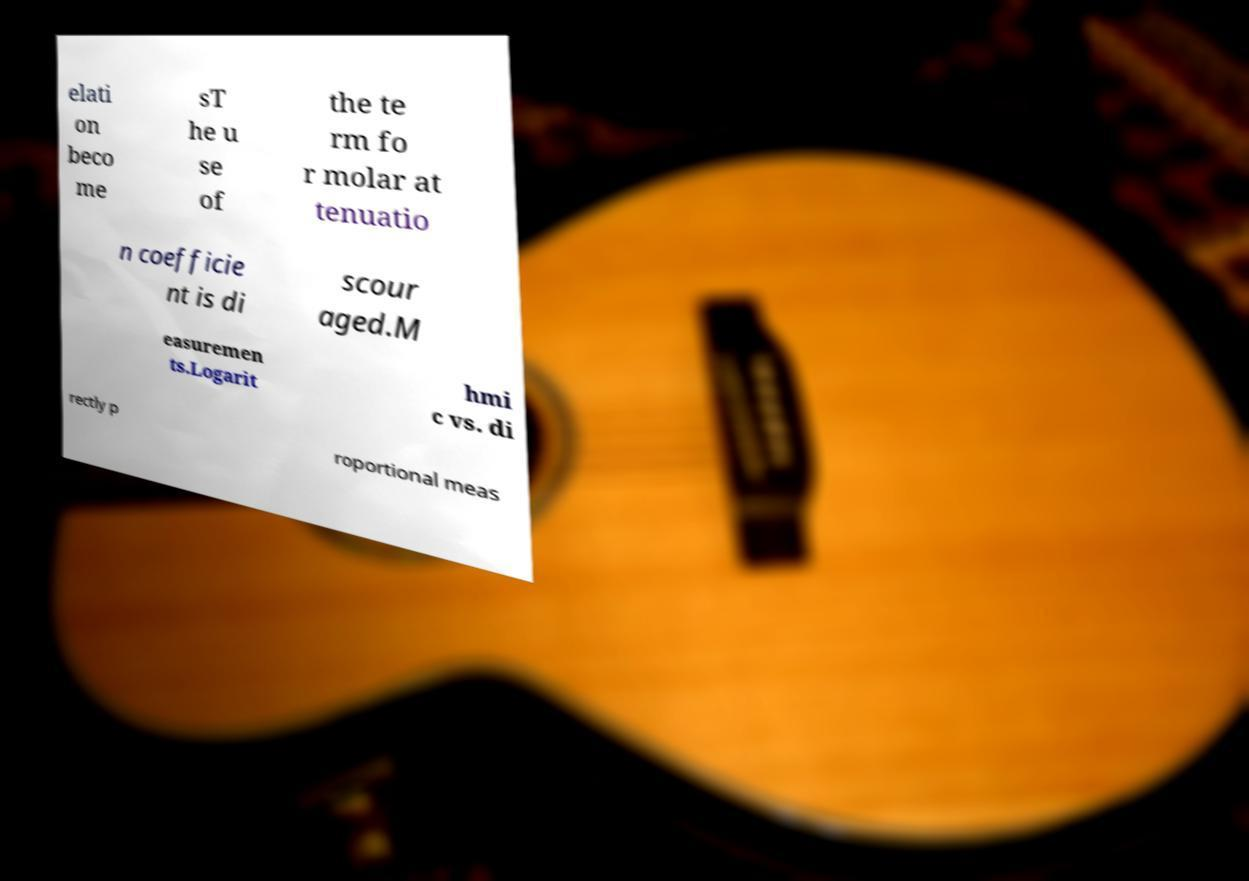I need the written content from this picture converted into text. Can you do that? elati on beco me sT he u se of the te rm fo r molar at tenuatio n coefficie nt is di scour aged.M easuremen ts.Logarit hmi c vs. di rectly p roportional meas 